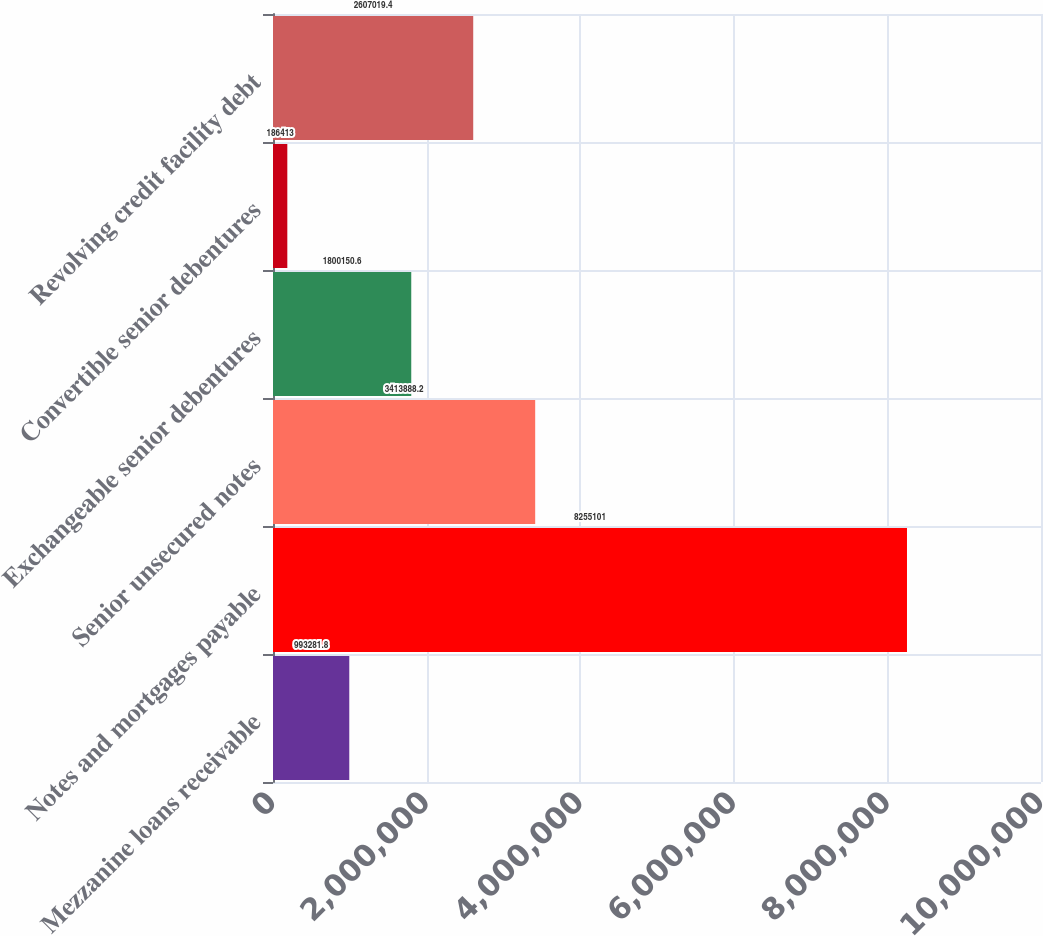Convert chart. <chart><loc_0><loc_0><loc_500><loc_500><bar_chart><fcel>Mezzanine loans receivable<fcel>Notes and mortgages payable<fcel>Senior unsecured notes<fcel>Exchangeable senior debentures<fcel>Convertible senior debentures<fcel>Revolving credit facility debt<nl><fcel>993282<fcel>8.2551e+06<fcel>3.41389e+06<fcel>1.80015e+06<fcel>186413<fcel>2.60702e+06<nl></chart> 